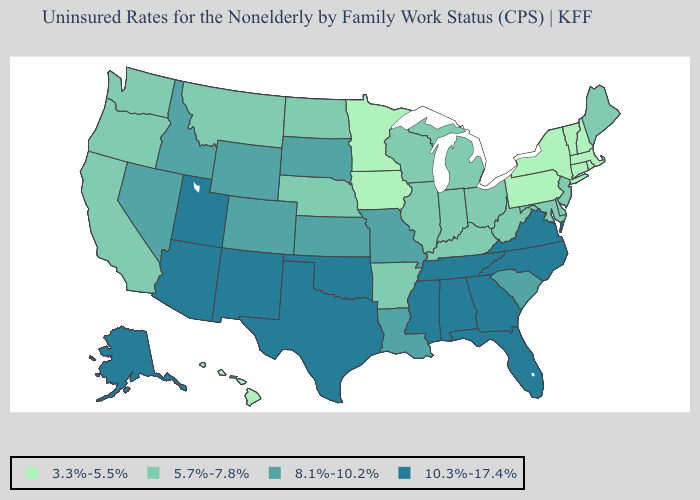Which states have the highest value in the USA?
Concise answer only. Alabama, Alaska, Arizona, Florida, Georgia, Mississippi, New Mexico, North Carolina, Oklahoma, Tennessee, Texas, Utah, Virginia. Name the states that have a value in the range 8.1%-10.2%?
Write a very short answer. Colorado, Idaho, Kansas, Louisiana, Missouri, Nevada, South Carolina, South Dakota, Wyoming. What is the highest value in the Northeast ?
Write a very short answer. 5.7%-7.8%. How many symbols are there in the legend?
Answer briefly. 4. Does the first symbol in the legend represent the smallest category?
Keep it brief. Yes. What is the highest value in states that border Kentucky?
Short answer required. 10.3%-17.4%. What is the lowest value in states that border Louisiana?
Be succinct. 5.7%-7.8%. What is the value of Washington?
Quick response, please. 5.7%-7.8%. Does the map have missing data?
Be succinct. No. What is the value of New Mexico?
Short answer required. 10.3%-17.4%. Does Massachusetts have the highest value in the Northeast?
Concise answer only. No. What is the value of West Virginia?
Write a very short answer. 5.7%-7.8%. Among the states that border Delaware , which have the lowest value?
Give a very brief answer. Pennsylvania. What is the lowest value in states that border South Carolina?
Concise answer only. 10.3%-17.4%. 